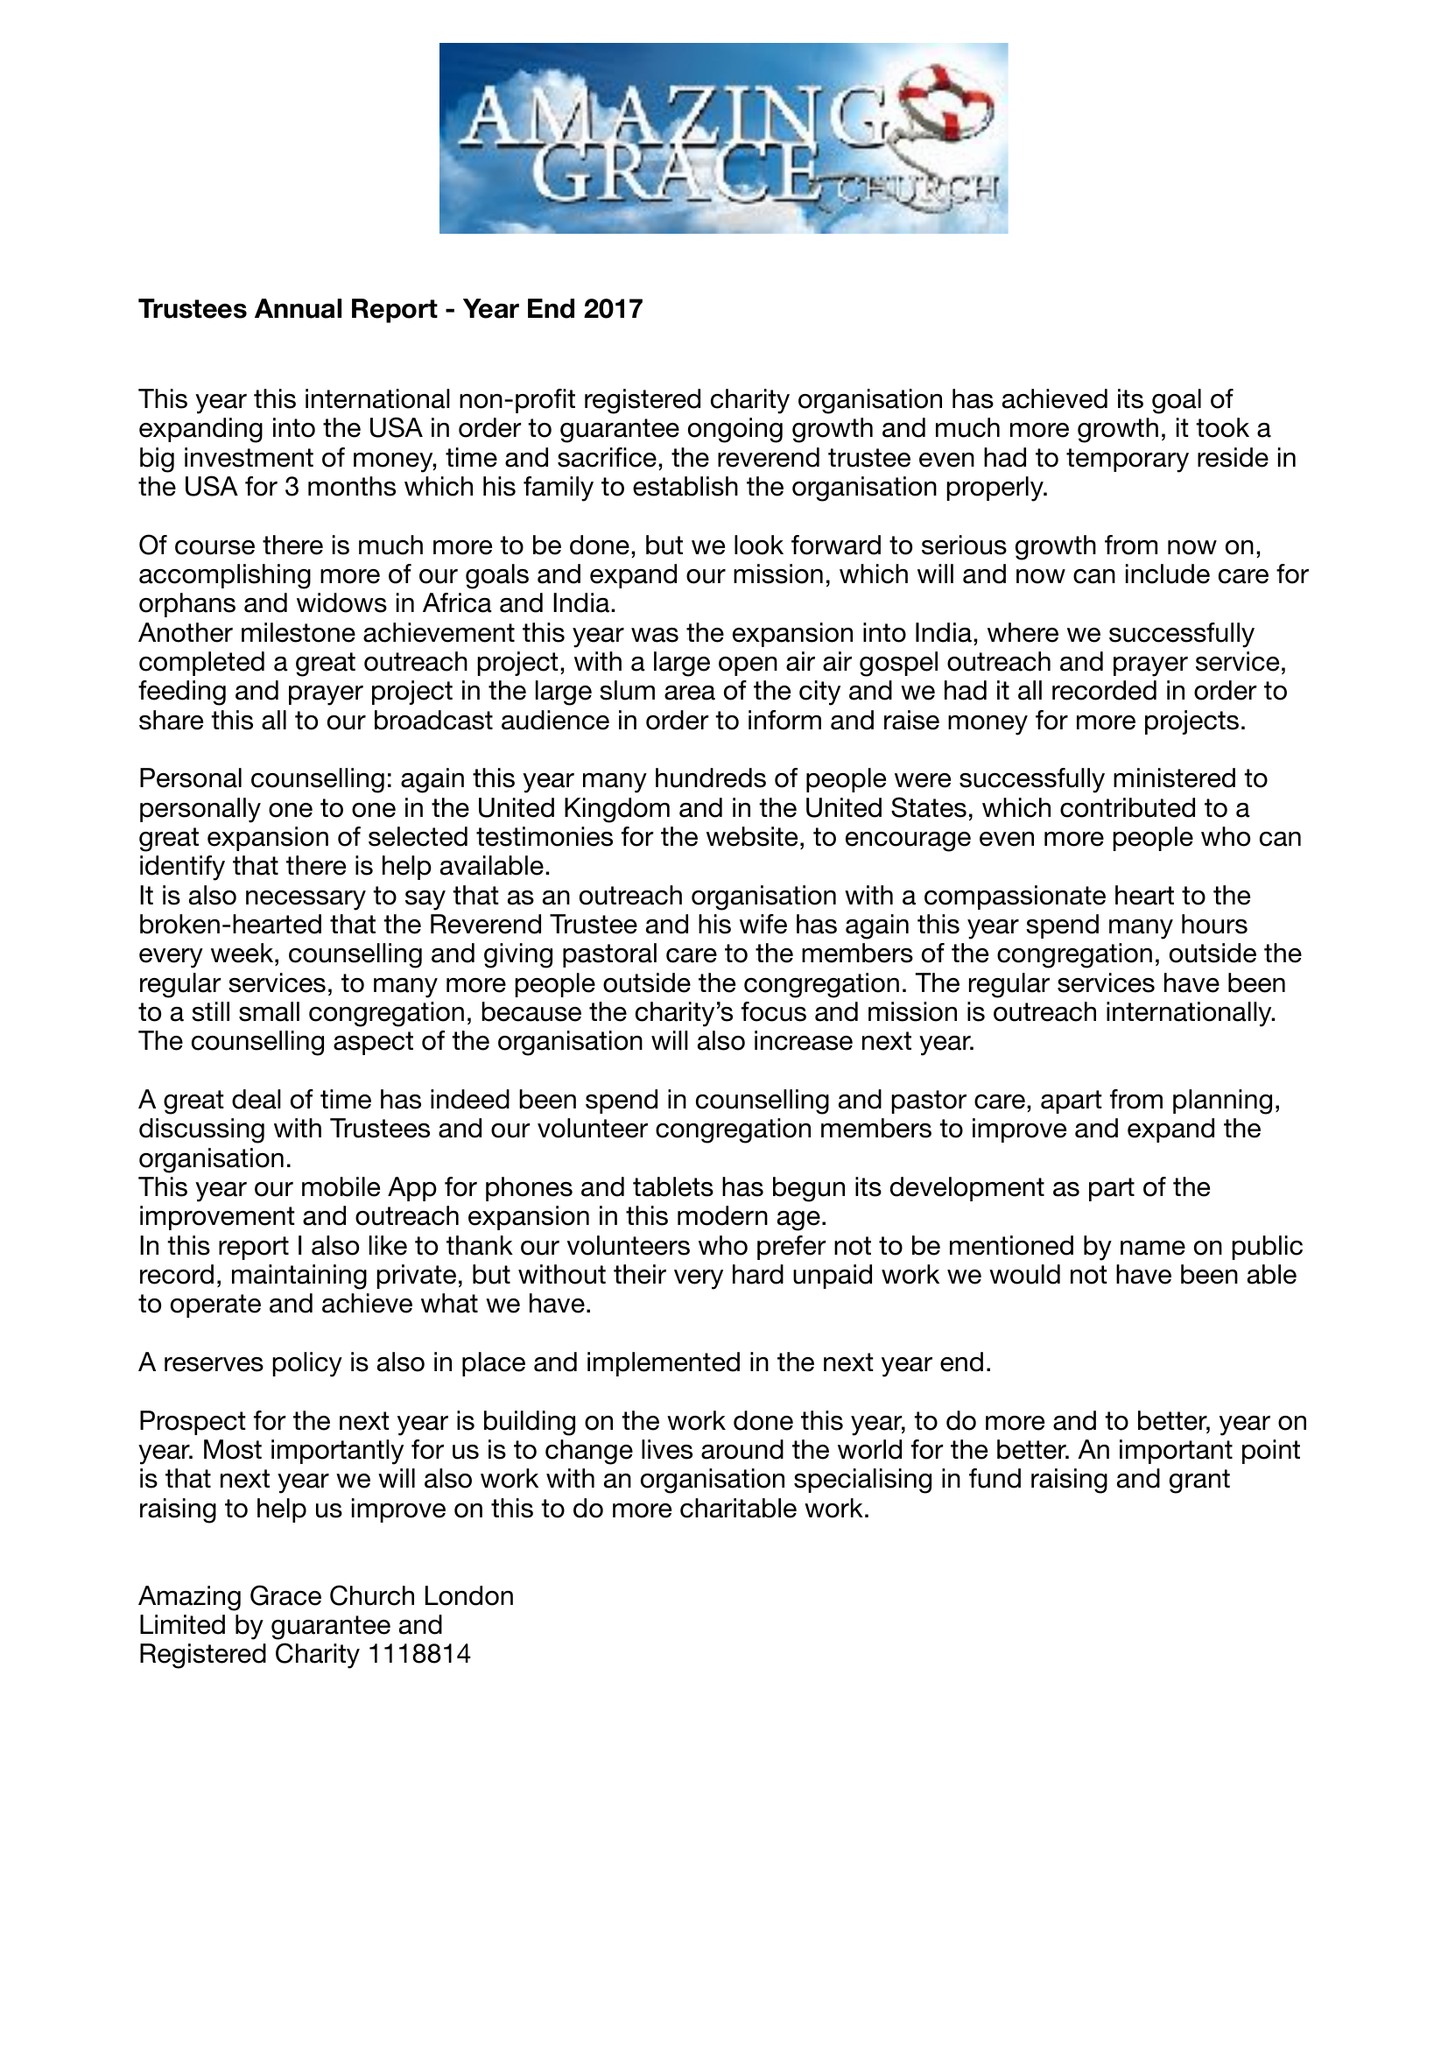What is the value for the report_date?
Answer the question using a single word or phrase. 2017-03-31 